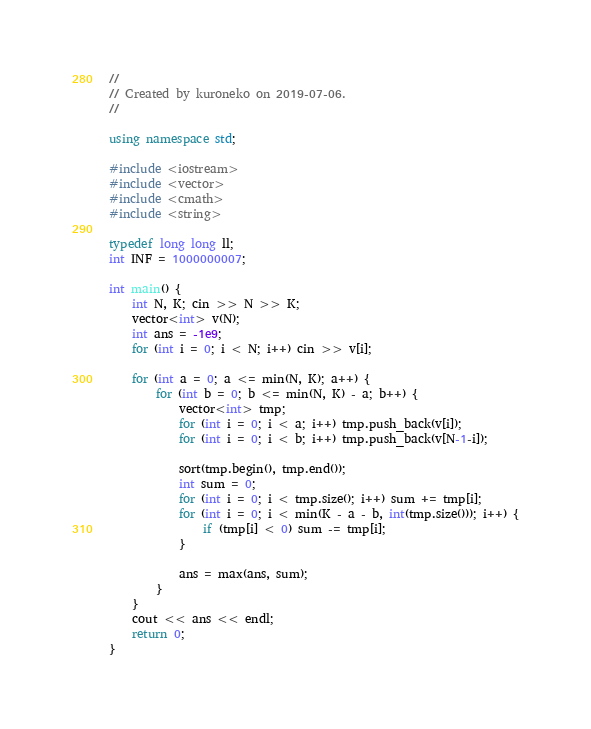Convert code to text. <code><loc_0><loc_0><loc_500><loc_500><_C++_>//
// Created by kuroneko on 2019-07-06.
//

using namespace std;

#include <iostream>
#include <vector>
#include <cmath>
#include <string>

typedef long long ll;
int INF = 1000000007;

int main() {
    int N, K; cin >> N >> K;
    vector<int> v(N);
    int ans = -1e9;
    for (int i = 0; i < N; i++) cin >> v[i];

    for (int a = 0; a <= min(N, K); a++) {
        for (int b = 0; b <= min(N, K) - a; b++) {
            vector<int> tmp;
            for (int i = 0; i < a; i++) tmp.push_back(v[i]);
            for (int i = 0; i < b; i++) tmp.push_back(v[N-1-i]);

            sort(tmp.begin(), tmp.end());
            int sum = 0;
            for (int i = 0; i < tmp.size(); i++) sum += tmp[i];
            for (int i = 0; i < min(K - a - b, int(tmp.size())); i++) {
                if (tmp[i] < 0) sum -= tmp[i];
            }

            ans = max(ans, sum);
        }
    }
    cout << ans << endl;
    return 0;
}</code> 